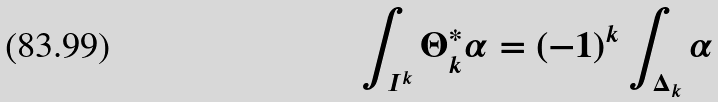<formula> <loc_0><loc_0><loc_500><loc_500>\int _ { I ^ { k } } \Theta _ { k } ^ { * } \alpha = ( - 1 ) ^ { k } \int _ { \Delta _ { k } } \alpha</formula> 